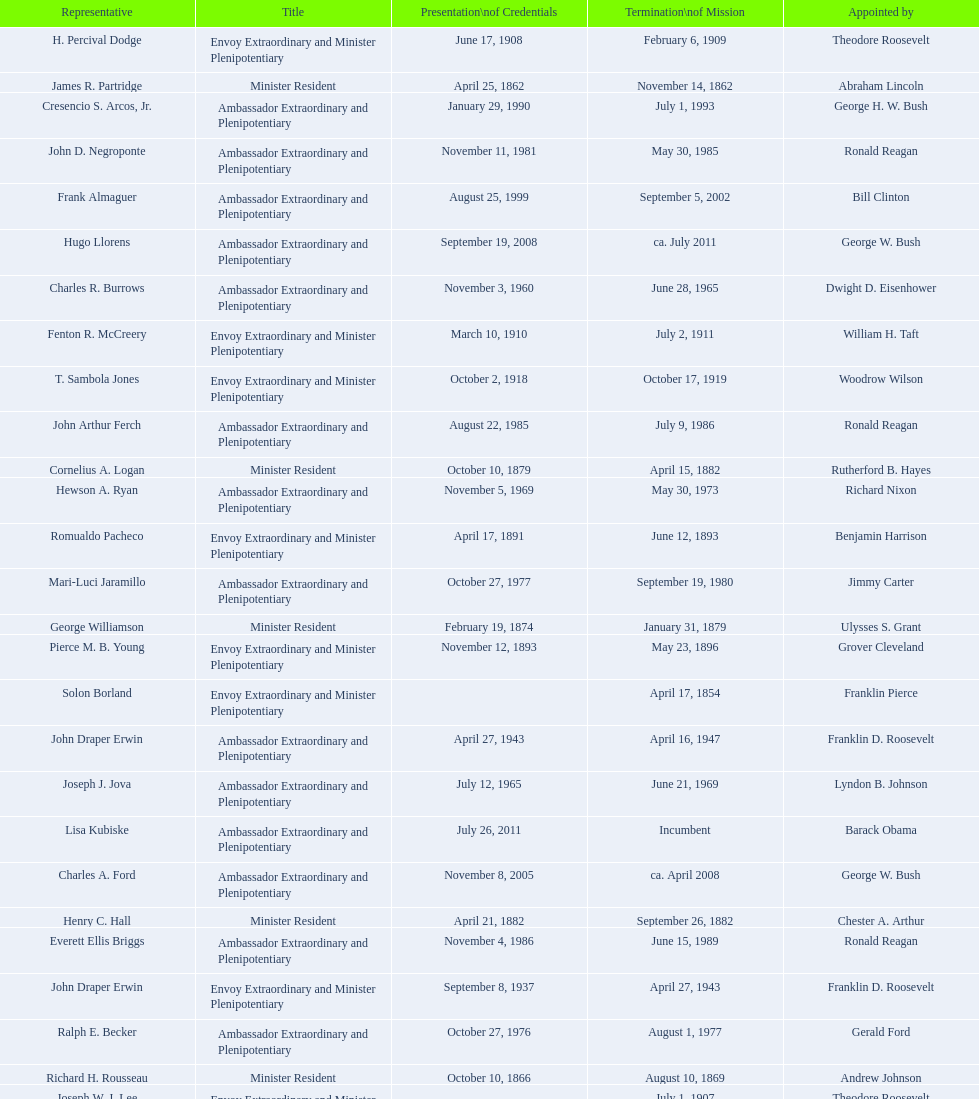Help me parse the entirety of this table. {'header': ['Representative', 'Title', 'Presentation\\nof Credentials', 'Termination\\nof Mission', 'Appointed by'], 'rows': [['H. Percival Dodge', 'Envoy Extraordinary and Minister Plenipotentiary', 'June 17, 1908', 'February 6, 1909', 'Theodore Roosevelt'], ['James R. Partridge', 'Minister Resident', 'April 25, 1862', 'November 14, 1862', 'Abraham Lincoln'], ['Cresencio S. Arcos, Jr.', 'Ambassador Extraordinary and Plenipotentiary', 'January 29, 1990', 'July 1, 1993', 'George H. W. Bush'], ['John D. Negroponte', 'Ambassador Extraordinary and Plenipotentiary', 'November 11, 1981', 'May 30, 1985', 'Ronald Reagan'], ['Frank Almaguer', 'Ambassador Extraordinary and Plenipotentiary', 'August 25, 1999', 'September 5, 2002', 'Bill Clinton'], ['Hugo Llorens', 'Ambassador Extraordinary and Plenipotentiary', 'September 19, 2008', 'ca. July 2011', 'George W. Bush'], ['Charles R. Burrows', 'Ambassador Extraordinary and Plenipotentiary', 'November 3, 1960', 'June 28, 1965', 'Dwight D. Eisenhower'], ['Fenton R. McCreery', 'Envoy Extraordinary and Minister Plenipotentiary', 'March 10, 1910', 'July 2, 1911', 'William H. Taft'], ['T. Sambola Jones', 'Envoy Extraordinary and Minister Plenipotentiary', 'October 2, 1918', 'October 17, 1919', 'Woodrow Wilson'], ['John Arthur Ferch', 'Ambassador Extraordinary and Plenipotentiary', 'August 22, 1985', 'July 9, 1986', 'Ronald Reagan'], ['Cornelius A. Logan', 'Minister Resident', 'October 10, 1879', 'April 15, 1882', 'Rutherford B. Hayes'], ['Hewson A. Ryan', 'Ambassador Extraordinary and Plenipotentiary', 'November 5, 1969', 'May 30, 1973', 'Richard Nixon'], ['Romualdo Pacheco', 'Envoy Extraordinary and Minister Plenipotentiary', 'April 17, 1891', 'June 12, 1893', 'Benjamin Harrison'], ['Mari-Luci Jaramillo', 'Ambassador Extraordinary and Plenipotentiary', 'October 27, 1977', 'September 19, 1980', 'Jimmy Carter'], ['George Williamson', 'Minister Resident', 'February 19, 1874', 'January 31, 1879', 'Ulysses S. Grant'], ['Pierce M. B. Young', 'Envoy Extraordinary and Minister Plenipotentiary', 'November 12, 1893', 'May 23, 1896', 'Grover Cleveland'], ['Solon Borland', 'Envoy Extraordinary and Minister Plenipotentiary', '', 'April 17, 1854', 'Franklin Pierce'], ['John Draper Erwin', 'Ambassador Extraordinary and Plenipotentiary', 'April 27, 1943', 'April 16, 1947', 'Franklin D. Roosevelt'], ['Joseph J. Jova', 'Ambassador Extraordinary and Plenipotentiary', 'July 12, 1965', 'June 21, 1969', 'Lyndon B. Johnson'], ['Lisa Kubiske', 'Ambassador Extraordinary and Plenipotentiary', 'July 26, 2011', 'Incumbent', 'Barack Obama'], ['Charles A. Ford', 'Ambassador Extraordinary and Plenipotentiary', 'November 8, 2005', 'ca. April 2008', 'George W. Bush'], ['Henry C. Hall', 'Minister Resident', 'April 21, 1882', 'September 26, 1882', 'Chester A. Arthur'], ['Everett Ellis Briggs', 'Ambassador Extraordinary and Plenipotentiary', 'November 4, 1986', 'June 15, 1989', 'Ronald Reagan'], ['John Draper Erwin', 'Envoy Extraordinary and Minister Plenipotentiary', 'September 8, 1937', 'April 27, 1943', 'Franklin D. Roosevelt'], ['Ralph E. Becker', 'Ambassador Extraordinary and Plenipotentiary', 'October 27, 1976', 'August 1, 1977', 'Gerald Ford'], ['Richard H. Rousseau', 'Minister Resident', 'October 10, 1866', 'August 10, 1869', 'Andrew Johnson'], ['Joseph W. J. Lee', 'Envoy Extraordinary and Minister Plenipotentiary', '', 'July 1, 1907', 'Theodore Roosevelt'], ['Franklin E. Morales', 'Envoy Extraordinary and Minister Plenipotentiary', 'January 18, 1922', 'March 2, 1925', 'Warren G. Harding'], ['Phillip V. Sanchez', 'Ambassador Extraordinary and Plenipotentiary', 'June 15, 1973', 'July 17, 1976', 'Richard Nixon'], ['George T. Summerlin', 'Envoy Extraordinary and Minister Plenipotentiary', 'November 21, 1925', 'December 17, 1929', 'Calvin Coolidge'], ['Beverly L. Clarke', 'Minister Resident', 'August 10, 1858', 'March 17, 1860', 'James Buchanan'], ['Henry Baxter', 'Minister Resident', 'August 10, 1869', 'June 30, 1873', 'Ulysses S. Grant'], ['Charles Dunning White', 'Envoy Extraordinary and Minister Plenipotentiary', 'September 9, 1911', 'November 4, 1913', 'William H. Taft'], ['Whiting Willauer', 'Ambassador Extraordinary and Plenipotentiary', 'March 5, 1954', 'March 24, 1958', 'Dwight D. Eisenhower'], ['Philip Marshall Brown', 'Envoy Extraordinary and Minister Plenipotentiary', 'February 21, 1909', 'February 26, 1910', 'Theodore Roosevelt'], ['Robert Newbegin', 'Ambassador Extraordinary and Plenipotentiary', 'April 30, 1958', 'August 3, 1960', 'Dwight D. Eisenhower'], ['Herbert S. Bursley', 'Ambassador Extraordinary and Plenipotentiary', 'May 15, 1948', 'December 12, 1950', 'Harry S. Truman'], ['Larry Leon Palmer', 'Ambassador Extraordinary and Plenipotentiary', 'October 8, 2002', 'May 7, 2005', 'George W. Bush'], ['William Thornton Pryce', 'Ambassador Extraordinary and Plenipotentiary', 'July 21, 1993', 'August 15, 1996', 'Bill Clinton'], ['John Draper Erwin', 'Ambassador Extraordinary and Plenipotentiary', 'March 14, 1951', 'February 28, 1954', 'Harry S. Truman'], ['James F. Creagan', 'Ambassador Extraordinary and Plenipotentiary', 'August 29, 1996', 'July 20, 1999', 'Bill Clinton'], ['Paul C. Daniels', 'Ambassador Extraordinary and Plenipotentiary', 'June 23, 1947', 'October 30, 1947', 'Harry S. Truman'], ['Leo J. Keena', 'Envoy Extraordinary and Minister Plenipotentiary', 'July 19, 1935', 'May 1, 1937', 'Franklin D. Roosevelt'], ['Macgrane Coxe', 'Envoy Extraordinary and Minister Plenipotentiary', '', 'June 30, 1897', 'Grover Cleveland'], ['W. Godfrey Hunter', 'Envoy Extraordinary and Minister Plenipotentiary', 'January 19, 1899', 'February 2, 1903', 'William McKinley'], ['Leslie Combs', 'Envoy Extraordinary and Minister Plenipotentiary', 'May 22, 1903', 'February 27, 1907', 'Theodore Roosevelt'], ['John Ewing', 'Envoy Extraordinary and Minister Plenipotentiary', 'December 26, 1913', 'January 18, 1918', 'Woodrow Wilson'], ['Lansing B. Mizner', 'Envoy Extraordinary and Minister Plenipotentiary', 'March 30, 1889', 'December 31, 1890', 'Benjamin Harrison'], ['Thomas H. Clay', 'Minister Resident', 'April 5, 1864', 'August 10, 1866', 'Abraham Lincoln'], ['Julius G. Lay', 'Envoy Extraordinary and Minister Plenipotentiary', 'May 31, 1930', 'March 17, 1935', 'Herbert Hoover'], ['Henry C. Hall', 'Envoy Extraordinary and Minister Plenipotentiary', 'September 26, 1882', 'May 16, 1889', 'Chester A. Arthur'], ['Jack R. Binns', 'Ambassador Extraordinary and Plenipotentiary', 'October 10, 1980', 'October 31, 1981', 'Jimmy Carter']]} Which date is below april 17, 1854 March 17, 1860. 